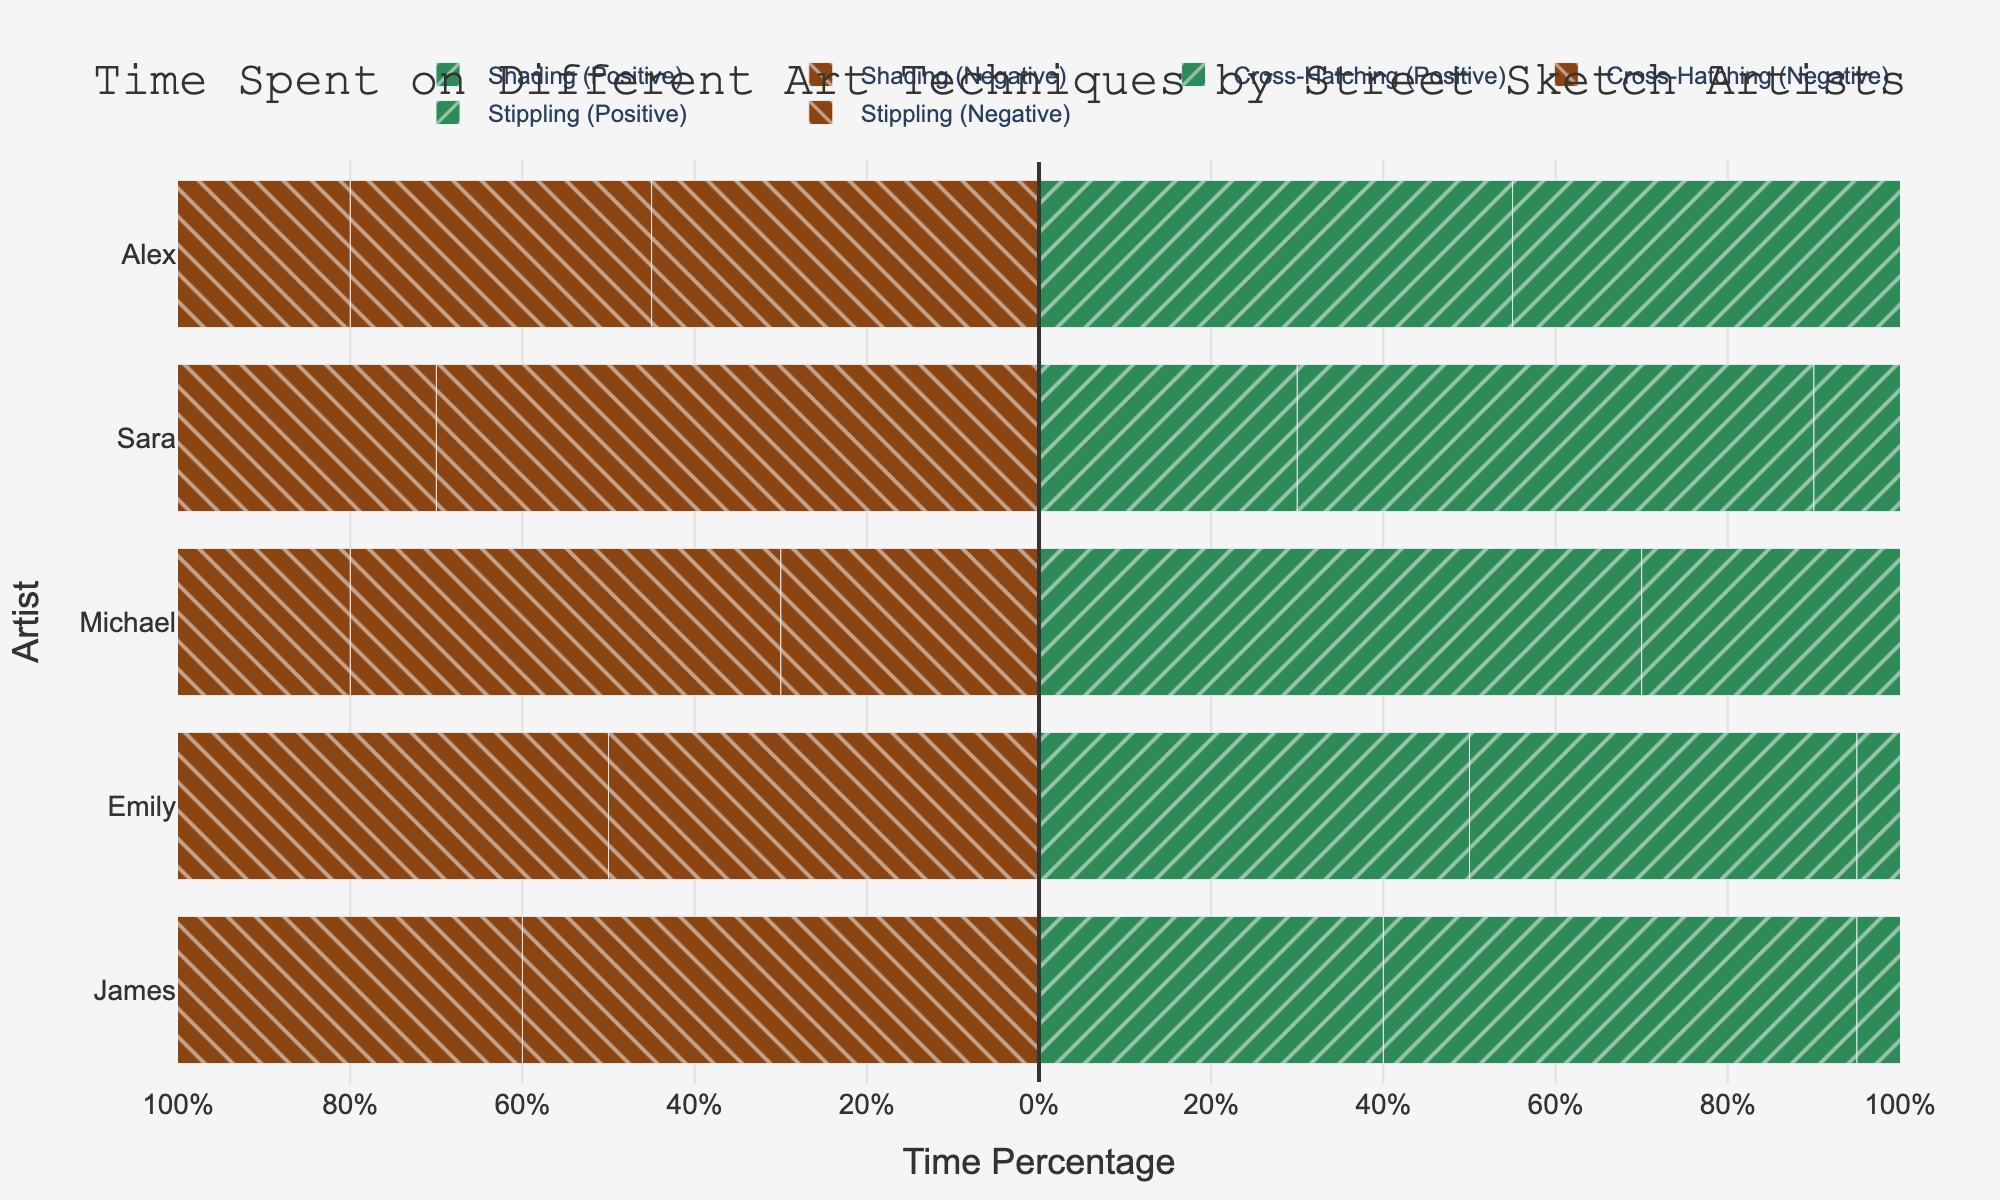What is the total positive time percentage spent on shading by Emily and Michael? For Emily, the positive time percentage for shading is 50%. For Michael, it is 70%. Sum these percentages: 50% + 70% = 120%.
Answer: 120% Which artist has the highest positive time percentage spent on stippling? Compare the positive time percentages spent on stippling by each artist: James (30%), Emily (60%), Michael (40%), Sara (50%), and Alex (35%). The highest percentage is 60% by Emily.
Answer: Emily What is the difference in positive time percentage spent on cross-hatching between James and Alex? James has a positive time percentage of 55% for cross-hatching, while Alex has 65%. The difference is 65% - 55% = 10%.
Answer: 10% Which technique has the greatest negative time percentage for James? James spends 70% on stippling, 60% on shading, and 45% on cross-hatching negatively. The highest negative percentage is 70% for stippling.
Answer: Stippling How much more time percentage does Michael spend positively on shading compared to Sara? Michael spends 70% of his time positively on shading, while Sara spends 30%. The difference is 70% - 30% = 40%.
Answer: 40% Which artist has an equal proportion of positive and negative time percentages for any of the techniques? Positive and negative percentages would be equal at 50%. Emily has 50/50 for shading, Michael has 50/50 for cross-hatching, and Sara has 50/50 for stippling.
Answer: Emily, Michael, and Sara What is the total negative time percentage spent on stippling by Emily and Alex? Emily spends 40% negatively on stippling, and Alex spends 65%. Sum these percentages: 40% + 65% = 105%.
Answer: 105% What is the average positive time percentage spent by all artists on cross-hatching? The positive time percentages for cross-hatching are: James (55%), Emily (45%), Michael (50%), Sara (60%), and Alex (65%). Calculate the average: (55% + 45% + 50% + 60% + 65%) / 5 = 55%.
Answer: 55% What is the sum of negative time percentages spent on shading by all artists? The negative time percentages spent on shading are: James 60%, Emily 50%, Michael 30%, Sara 70%, and Alex 45%. Sum these percentages: 60% + 50% + 30% + 70% + 45% = 255%.
Answer: 255% 